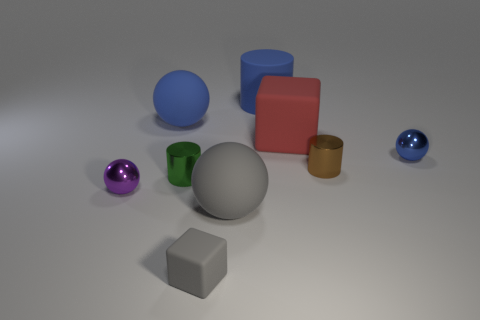Subtract all purple balls. How many balls are left? 3 Subtract all red cubes. How many cubes are left? 1 Subtract all cylinders. How many objects are left? 6 Add 9 small blue metal spheres. How many small blue metal spheres are left? 10 Add 4 red objects. How many red objects exist? 5 Subtract 0 yellow blocks. How many objects are left? 9 Subtract 3 balls. How many balls are left? 1 Subtract all gray cylinders. Subtract all yellow balls. How many cylinders are left? 3 Subtract all blue cylinders. How many blue spheres are left? 2 Subtract all big blue things. Subtract all big blue cylinders. How many objects are left? 6 